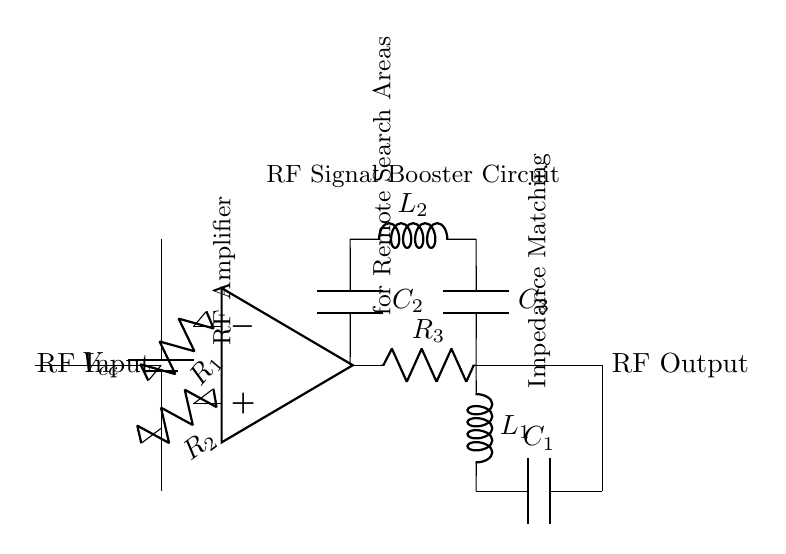What does the circuit aim to boost? The circuit's purpose is to enhance the Radio Frequency signal for communication, specifically designed for remote search areas.
Answer: RF signal What type of components are used in the amplifier section? The amplifier section consists of resistors, represented as R1, R2, and R3, and an operational amplifier is depicted as the op amp.
Answer: Resistors and op amp How many capacitors are in the circuit? There are three capacitors represented, specifically C1, C2, and C3, each serving different functions in the circuit.
Answer: Three What is the function of L1 and L2 in the circuit? L1 and L2 are inductors used in the impedance matching network and tuning circuit, respectively, to optimize the signal strength and matching.
Answer: To match impedance and tune the circuit What connection does the RF output have? The RF output is connected to an antenna which enables communication after amplification, allowing the boosted signal to be transmitted.
Answer: Antenna Which components form the impedance matching network? The impedance matching network consists of L1 and C1, which work together to ensure maximum power transfer from the amplifier to the output load.
Answer: L1 and C1 